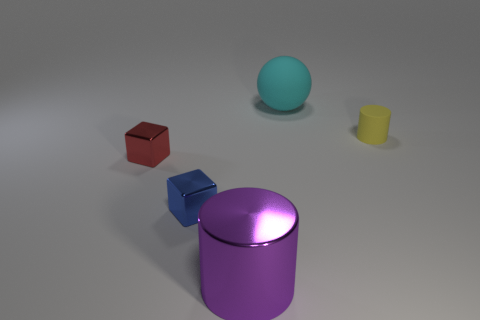Is the number of tiny metal things on the right side of the blue cube greater than the number of red shiny things?
Keep it short and to the point. No. Are there any small red things of the same shape as the large purple thing?
Keep it short and to the point. No. What number of objects are either tiny rubber cylinders or big yellow metallic blocks?
Provide a short and direct response. 1. There is a big thing that is in front of the small yellow rubber thing in front of the big matte thing; what number of cylinders are on the right side of it?
Keep it short and to the point. 1. There is a purple object that is the same shape as the tiny yellow rubber thing; what is its material?
Your answer should be very brief. Metal. There is a thing that is both to the left of the rubber cylinder and behind the small red metallic block; what material is it made of?
Your answer should be very brief. Rubber. Are there fewer big cyan matte objects behind the matte sphere than red cubes behind the tiny red cube?
Your answer should be very brief. No. What number of other objects are there of the same size as the sphere?
Ensure brevity in your answer.  1. There is a matte object in front of the large object behind the tiny shiny block to the right of the tiny red object; what is its shape?
Your answer should be compact. Cylinder. What number of red things are big cylinders or matte cylinders?
Your response must be concise. 0. 